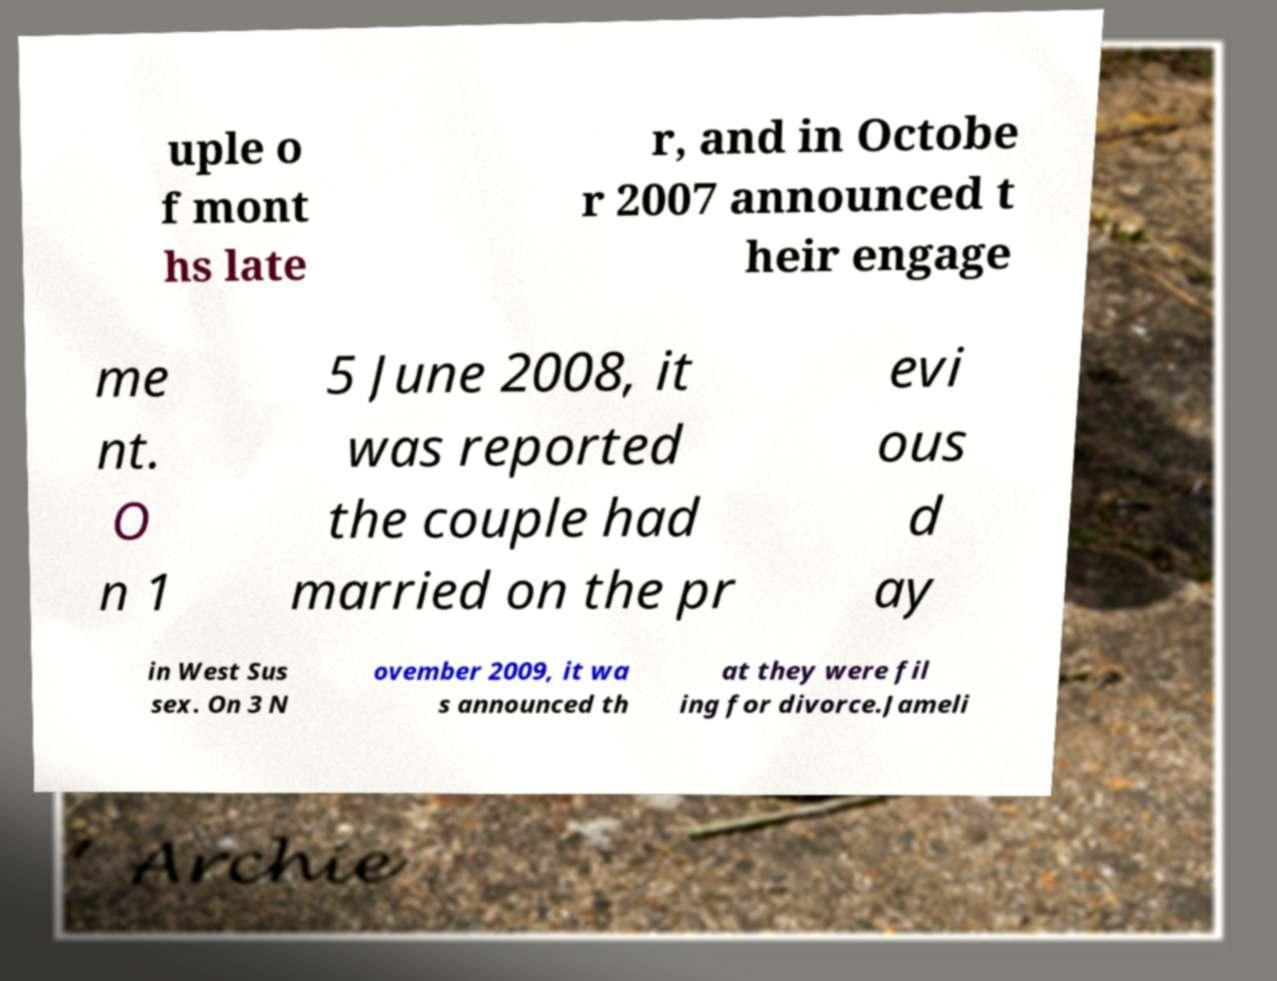Could you assist in decoding the text presented in this image and type it out clearly? uple o f mont hs late r, and in Octobe r 2007 announced t heir engage me nt. O n 1 5 June 2008, it was reported the couple had married on the pr evi ous d ay in West Sus sex. On 3 N ovember 2009, it wa s announced th at they were fil ing for divorce.Jameli 